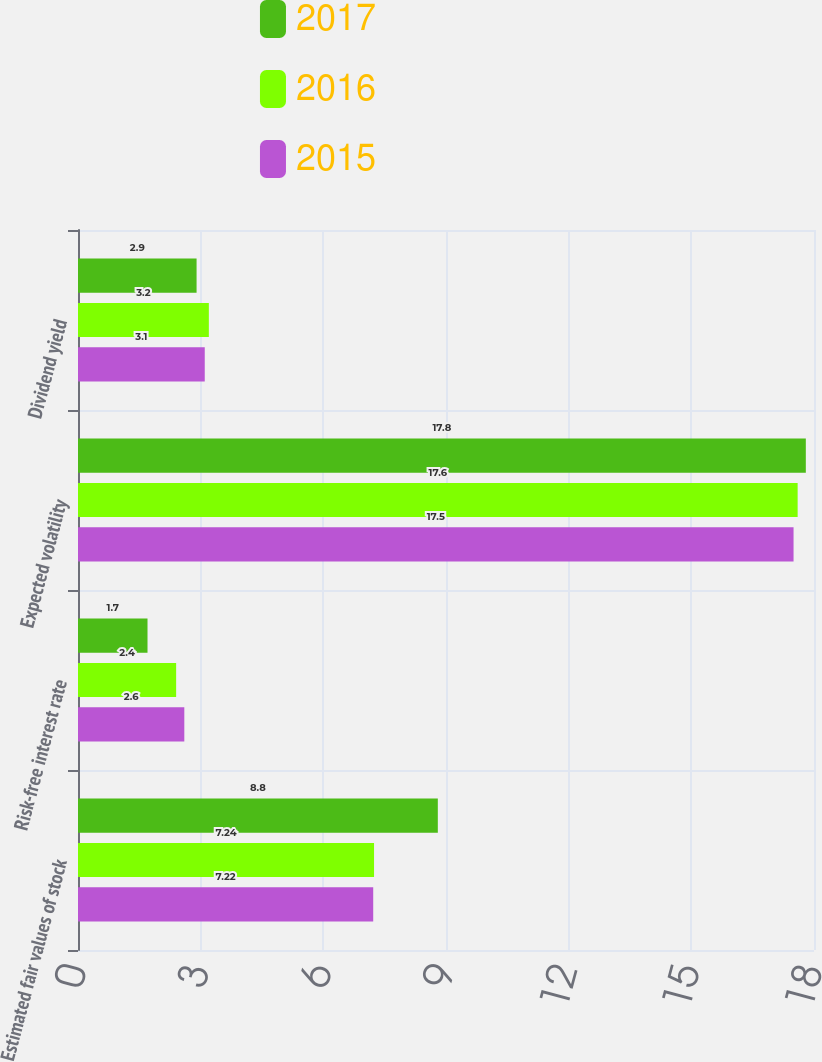Convert chart. <chart><loc_0><loc_0><loc_500><loc_500><stacked_bar_chart><ecel><fcel>Estimated fair values of stock<fcel>Risk-free interest rate<fcel>Expected volatility<fcel>Dividend yield<nl><fcel>2017<fcel>8.8<fcel>1.7<fcel>17.8<fcel>2.9<nl><fcel>2016<fcel>7.24<fcel>2.4<fcel>17.6<fcel>3.2<nl><fcel>2015<fcel>7.22<fcel>2.6<fcel>17.5<fcel>3.1<nl></chart> 